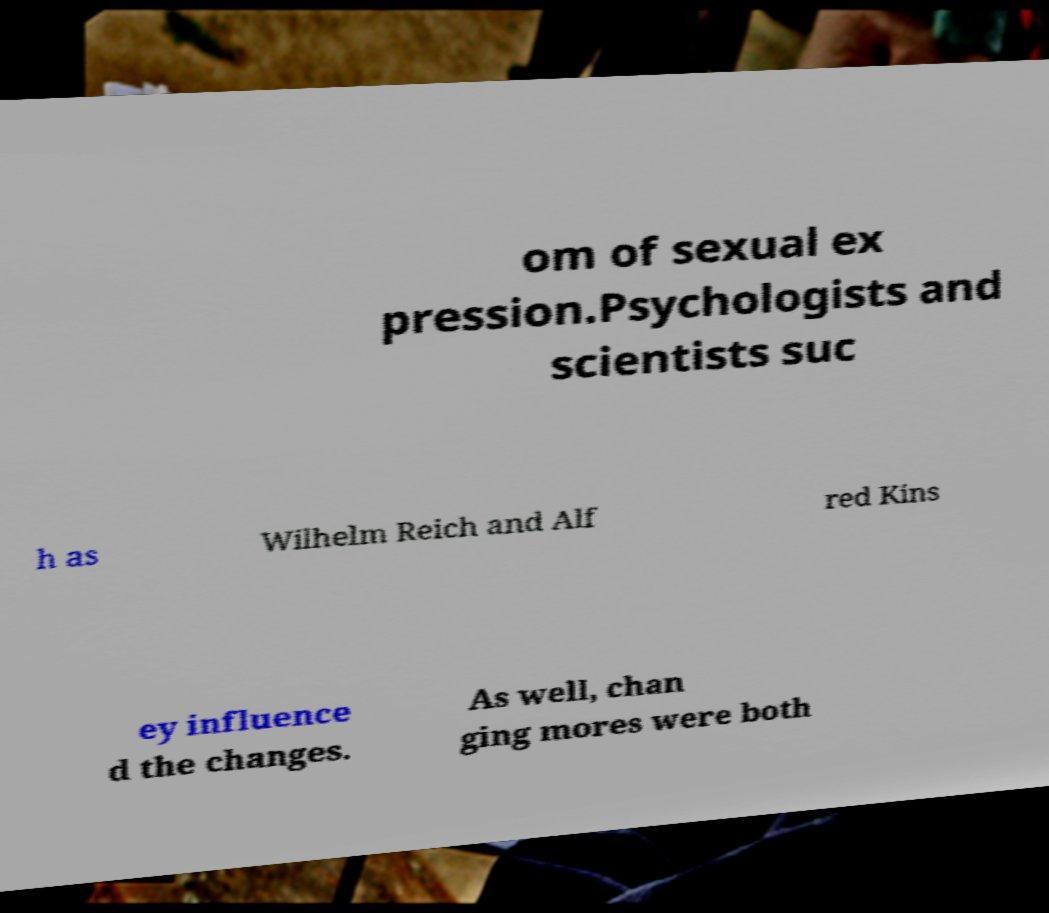Please identify and transcribe the text found in this image. om of sexual ex pression.Psychologists and scientists suc h as Wilhelm Reich and Alf red Kins ey influence d the changes. As well, chan ging mores were both 